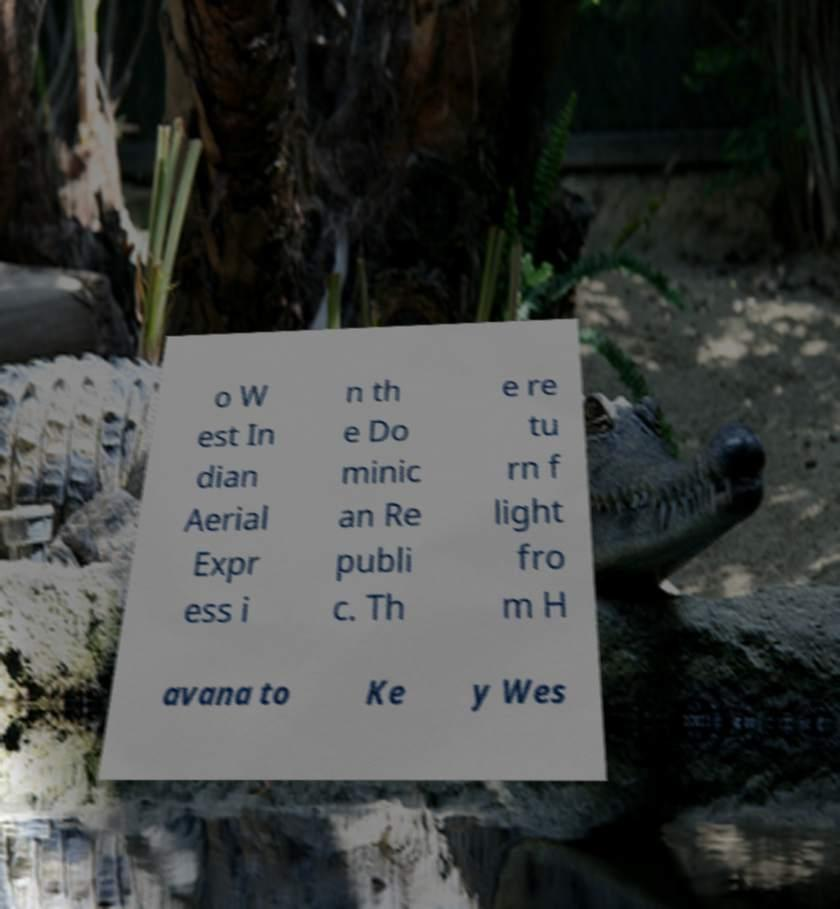What messages or text are displayed in this image? I need them in a readable, typed format. o W est In dian Aerial Expr ess i n th e Do minic an Re publi c. Th e re tu rn f light fro m H avana to Ke y Wes 